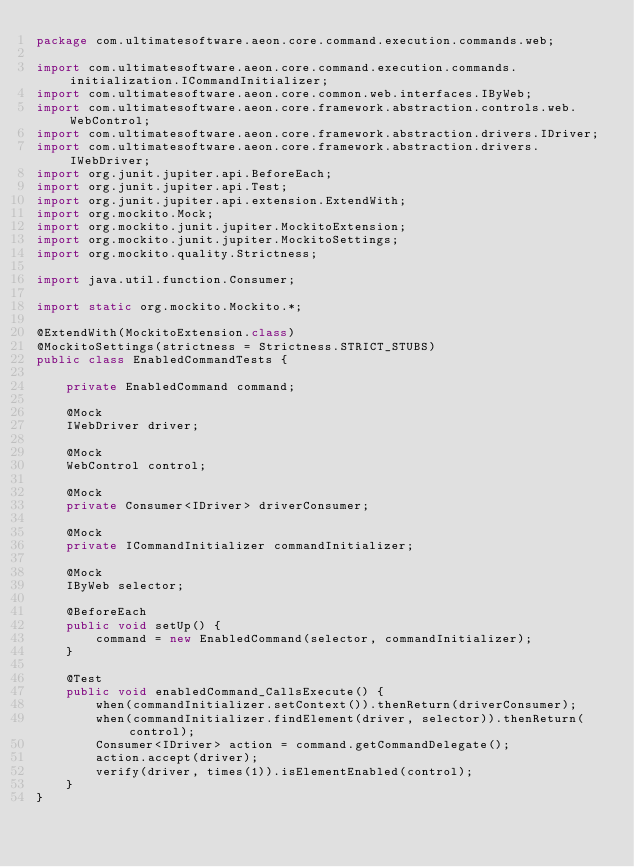<code> <loc_0><loc_0><loc_500><loc_500><_Java_>package com.ultimatesoftware.aeon.core.command.execution.commands.web;

import com.ultimatesoftware.aeon.core.command.execution.commands.initialization.ICommandInitializer;
import com.ultimatesoftware.aeon.core.common.web.interfaces.IByWeb;
import com.ultimatesoftware.aeon.core.framework.abstraction.controls.web.WebControl;
import com.ultimatesoftware.aeon.core.framework.abstraction.drivers.IDriver;
import com.ultimatesoftware.aeon.core.framework.abstraction.drivers.IWebDriver;
import org.junit.jupiter.api.BeforeEach;
import org.junit.jupiter.api.Test;
import org.junit.jupiter.api.extension.ExtendWith;
import org.mockito.Mock;
import org.mockito.junit.jupiter.MockitoExtension;
import org.mockito.junit.jupiter.MockitoSettings;
import org.mockito.quality.Strictness;

import java.util.function.Consumer;

import static org.mockito.Mockito.*;

@ExtendWith(MockitoExtension.class)
@MockitoSettings(strictness = Strictness.STRICT_STUBS)
public class EnabledCommandTests {

    private EnabledCommand command;

    @Mock
    IWebDriver driver;

    @Mock
    WebControl control;

    @Mock
    private Consumer<IDriver> driverConsumer;

    @Mock
    private ICommandInitializer commandInitializer;

    @Mock
    IByWeb selector;

    @BeforeEach
    public void setUp() {
        command = new EnabledCommand(selector, commandInitializer);
    }

    @Test
    public void enabledCommand_CallsExecute() {
        when(commandInitializer.setContext()).thenReturn(driverConsumer);
        when(commandInitializer.findElement(driver, selector)).thenReturn(control);
        Consumer<IDriver> action = command.getCommandDelegate();
        action.accept(driver);
        verify(driver, times(1)).isElementEnabled(control);
    }
}
</code> 